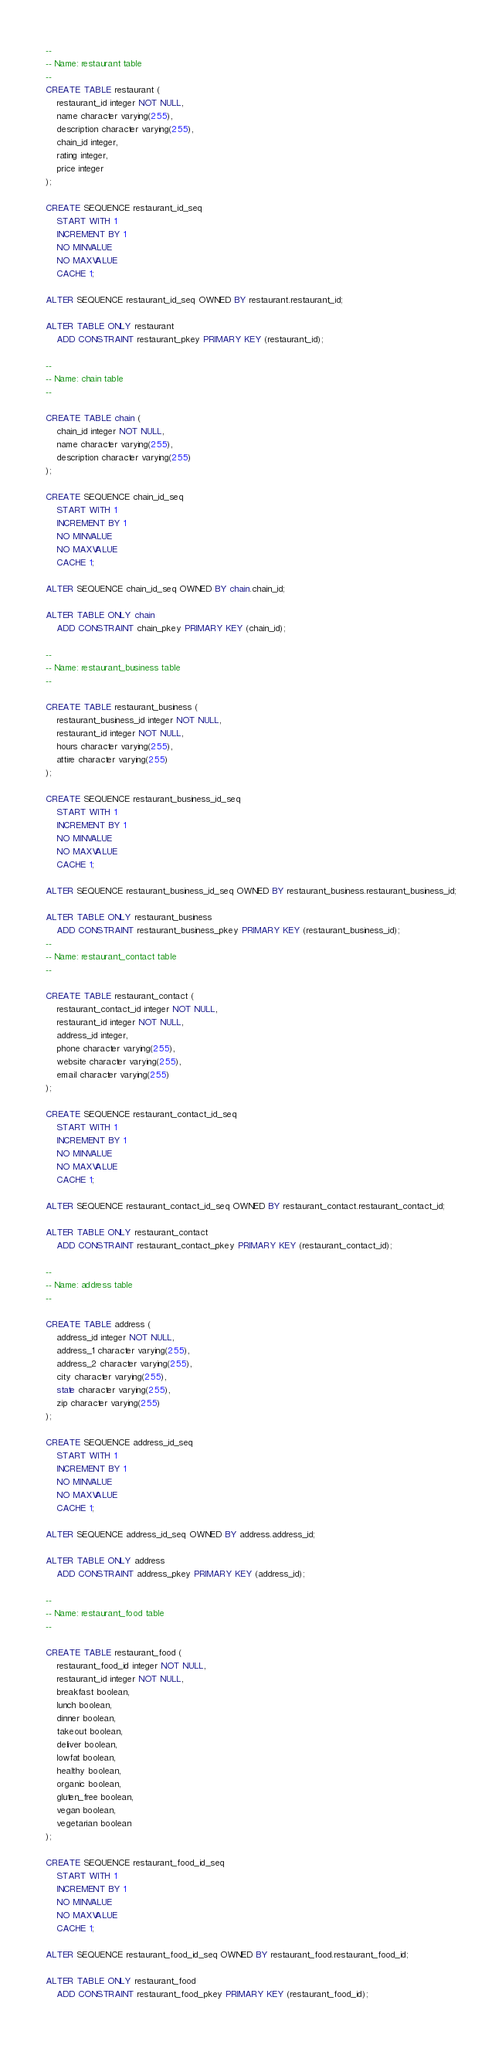<code> <loc_0><loc_0><loc_500><loc_500><_SQL_>
--
-- Name: restaurant table
--
CREATE TABLE restaurant (
    restaurant_id integer NOT NULL,
    name character varying(255),
    description character varying(255),
    chain_id integer,
    rating integer,
    price integer
);

CREATE SEQUENCE restaurant_id_seq
    START WITH 1
    INCREMENT BY 1
    NO MINVALUE
    NO MAXVALUE
    CACHE 1;

ALTER SEQUENCE restaurant_id_seq OWNED BY restaurant.restaurant_id;

ALTER TABLE ONLY restaurant
    ADD CONSTRAINT restaurant_pkey PRIMARY KEY (restaurant_id);

--
-- Name: chain table
--

CREATE TABLE chain (
    chain_id integer NOT NULL,
    name character varying(255),
    description character varying(255)
);

CREATE SEQUENCE chain_id_seq
    START WITH 1
    INCREMENT BY 1
    NO MINVALUE
    NO MAXVALUE
    CACHE 1;

ALTER SEQUENCE chain_id_seq OWNED BY chain.chain_id;

ALTER TABLE ONLY chain
    ADD CONSTRAINT chain_pkey PRIMARY KEY (chain_id);

--
-- Name: restaurant_business table
--

CREATE TABLE restaurant_business (
	restaurant_business_id integer NOT NULL,
    restaurant_id integer NOT NULL,
    hours character varying(255),
    attire character varying(255)
);

CREATE SEQUENCE restaurant_business_id_seq
    START WITH 1
    INCREMENT BY 1
    NO MINVALUE
    NO MAXVALUE
    CACHE 1;

ALTER SEQUENCE restaurant_business_id_seq OWNED BY restaurant_business.restaurant_business_id;

ALTER TABLE ONLY restaurant_business
    ADD CONSTRAINT restaurant_business_pkey PRIMARY KEY (restaurant_business_id);
--
-- Name: restaurant_contact table
--

CREATE TABLE restaurant_contact (
    restaurant_contact_id integer NOT NULL,
    restaurant_id integer NOT NULL,
    address_id integer,
    phone character varying(255),
    website character varying(255),
    email character varying(255)
);

CREATE SEQUENCE restaurant_contact_id_seq
    START WITH 1
    INCREMENT BY 1
    NO MINVALUE
    NO MAXVALUE
    CACHE 1;

ALTER SEQUENCE restaurant_contact_id_seq OWNED BY restaurant_contact.restaurant_contact_id;

ALTER TABLE ONLY restaurant_contact
    ADD CONSTRAINT restaurant_contact_pkey PRIMARY KEY (restaurant_contact_id);

--
-- Name: address table
--

CREATE TABLE address (
	address_id integer NOT NULL,
	address_1 character varying(255),
    address_2 character varying(255),
    city character varying(255),
    state character varying(255),
    zip character varying(255)
);

CREATE SEQUENCE address_id_seq
    START WITH 1
    INCREMENT BY 1
    NO MINVALUE
    NO MAXVALUE
    CACHE 1;

ALTER SEQUENCE address_id_seq OWNED BY address.address_id;

ALTER TABLE ONLY address
    ADD CONSTRAINT address_pkey PRIMARY KEY (address_id);

--
-- Name: restaurant_food table
--

CREATE TABLE restaurant_food (
	restaurant_food_id integer NOT NULL,
    restaurant_id integer NOT NULL,
    breakfast boolean,
    lunch boolean,
    dinner boolean,
    takeout boolean,
    deliver boolean,
    lowfat boolean,
    healthy boolean,
    organic boolean,
    gluten_free boolean,
    vegan boolean,
    vegetarian boolean
);

CREATE SEQUENCE restaurant_food_id_seq
    START WITH 1
    INCREMENT BY 1
    NO MINVALUE
    NO MAXVALUE
    CACHE 1;

ALTER SEQUENCE restaurant_food_id_seq OWNED BY restaurant_food.restaurant_food_id;

ALTER TABLE ONLY restaurant_food
    ADD CONSTRAINT restaurant_food_pkey PRIMARY KEY (restaurant_food_id);

</code> 